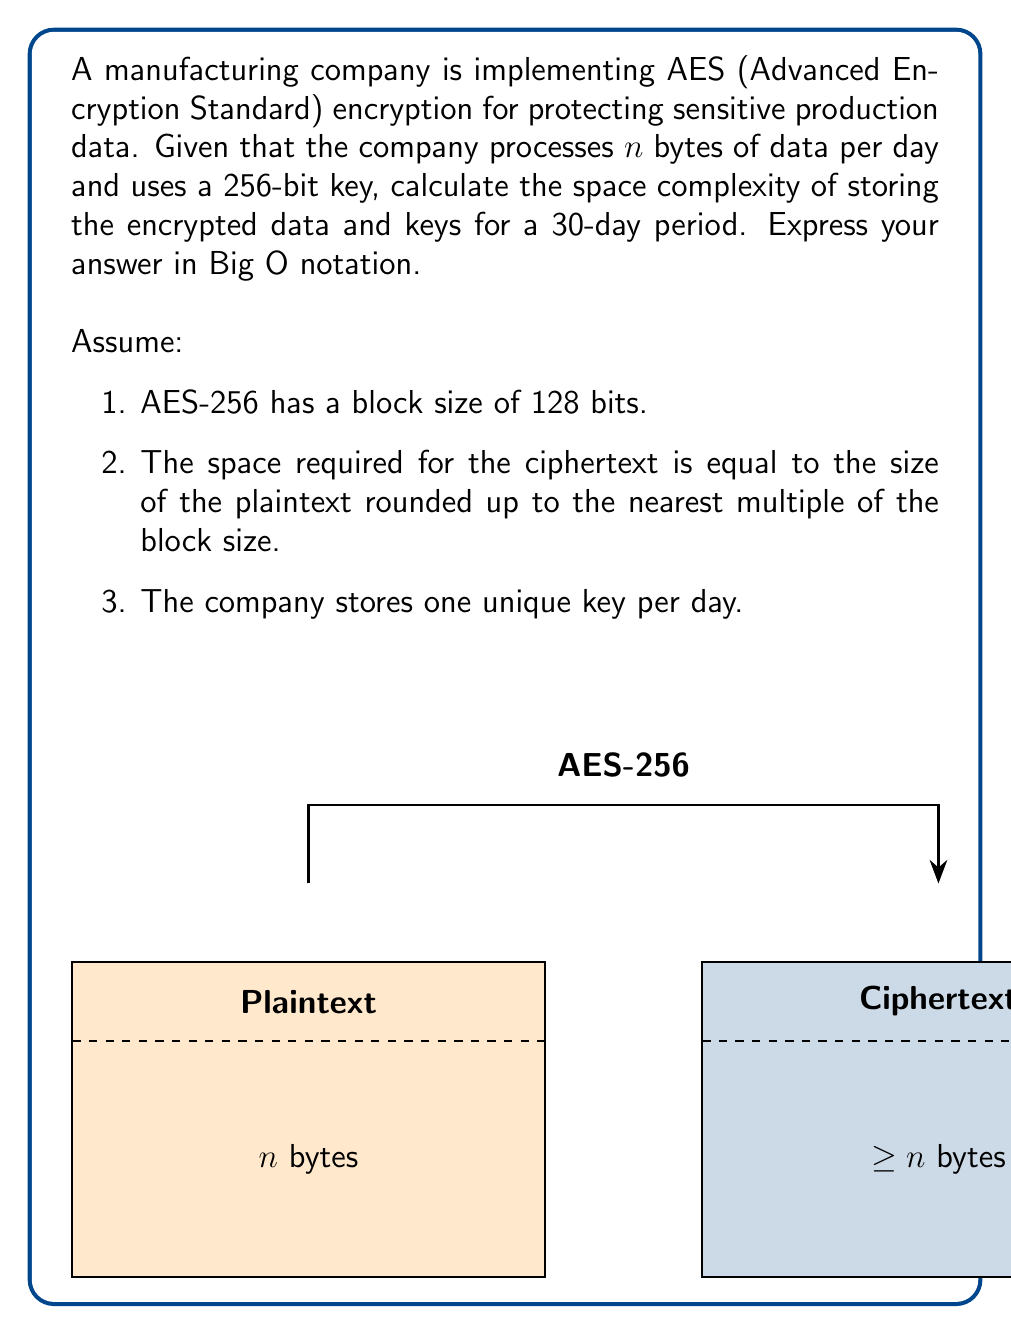Provide a solution to this math problem. Let's approach this step-by-step:

1) First, let's consider the space required for the encrypted data:
   - Each day, $n$ bytes of data are processed.
   - AES has a block size of 128 bits = 16 bytes.
   - The ciphertext size will be $n$ rounded up to the nearest multiple of 16.
   - We can express this as: $16 \cdot \lceil \frac{n}{16} \rceil$ bytes per day.
   - For 30 days, this becomes: $30 \cdot 16 \cdot \lceil \frac{n}{16} \rceil$ bytes.

2) Now, let's consider the space required for the keys:
   - Each key is 256 bits = 32 bytes.
   - One key is stored per day for 30 days.
   - Total space for keys: $30 \cdot 32 = 960$ bytes.

3) The total space required is the sum of the space for encrypted data and keys:
   $$ 30 \cdot 16 \cdot \lceil \frac{n}{16} \rceil + 960 $$

4) Simplifying:
   $$ 480 \cdot \lceil \frac{n}{16} \rceil + 960 $$

5) In terms of $n$, as $n$ grows large, the ceiling function becomes negligible, and we can approximate this as:
   $$ 480 \cdot \frac{n}{16} + 960 = 30n + 960 $$

6) In Big O notation, we ignore constant factors and lower-order terms. Therefore, the space complexity is $O(n)$.
Answer: $O(n)$ 